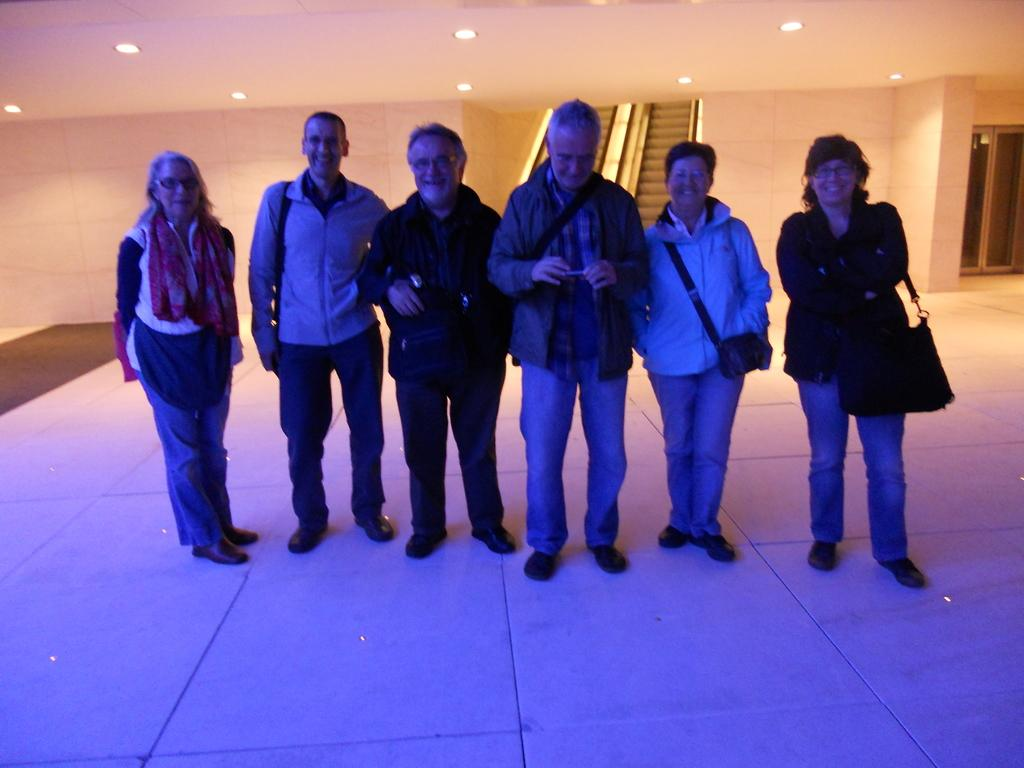How many people are in the image? There are six persons in the image. What are the people in the image doing? The persons are standing on the floor and smiling. What can be seen in the background of the image? There is a wall, a door, and lights in the background of the image. What type of copy machine is visible in the image? There is no copy machine present in the image. What type of plough is being used by the persons in the image? There are no ploughs or farming activities depicted in the image. 